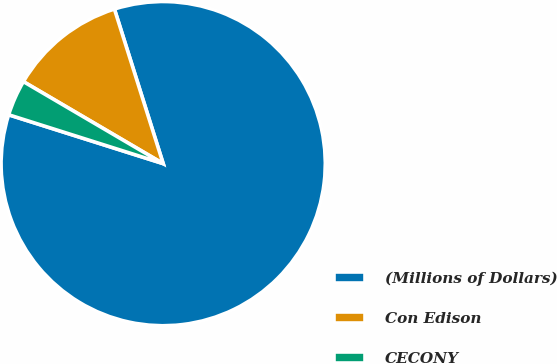<chart> <loc_0><loc_0><loc_500><loc_500><pie_chart><fcel>(Millions of Dollars)<fcel>Con Edison<fcel>CECONY<nl><fcel>84.74%<fcel>11.69%<fcel>3.57%<nl></chart> 